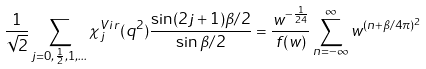Convert formula to latex. <formula><loc_0><loc_0><loc_500><loc_500>\frac { 1 } { \sqrt { 2 } } \sum _ { j = 0 , \frac { 1 } { 2 } , 1 , \dots } \chi _ { j } ^ { V i r } ( q ^ { 2 } ) \frac { \sin ( 2 j + 1 ) \beta / 2 } { \sin \beta / 2 } = \frac { w ^ { - \frac { 1 } { 2 4 } } } { f ( w ) } \sum _ { n = - \infty } ^ { \infty } w ^ { ( n + \beta / 4 \pi ) ^ { 2 } }</formula> 